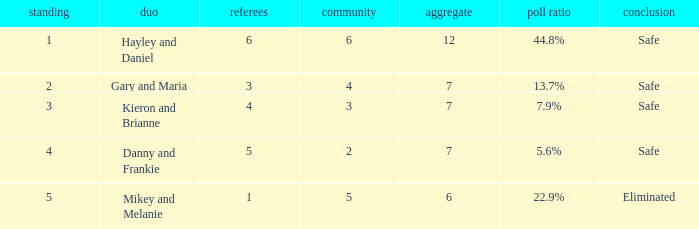What was the total number when the vote percentage was 44.8%? 1.0. 